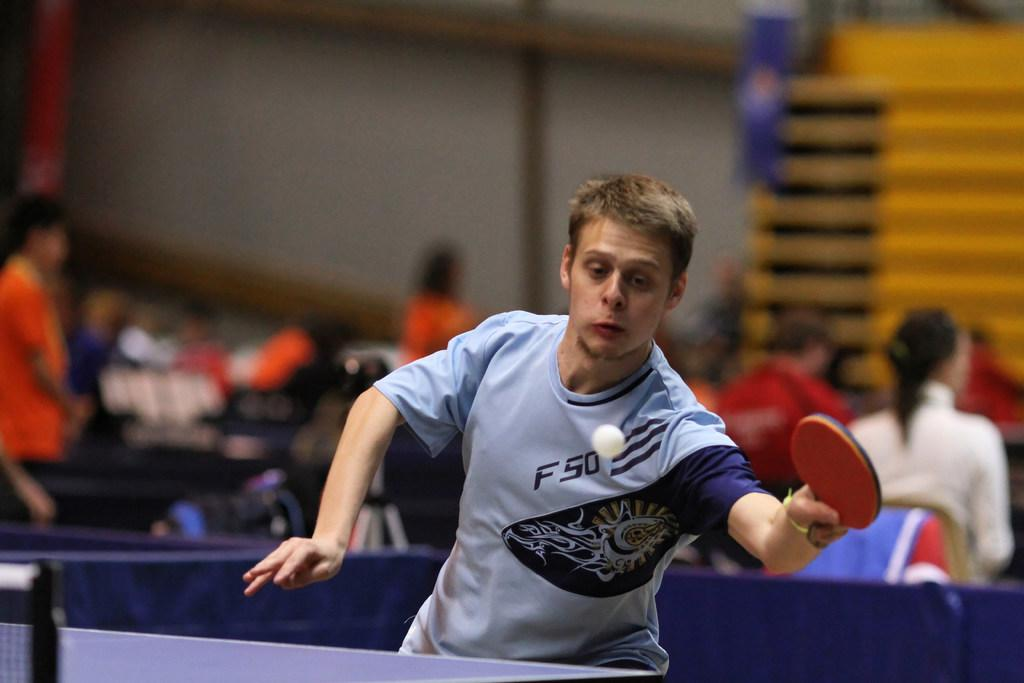What is the person in the image holding? The person in the image is holding a bat. How is the bat being held by the person? The person is holding the bat in his hand. What other object is present in the image? There is a ball in the image. What can be observed about the people in the background of the image? There are people sitting and standing in the background of the image. What type of tax is being discussed by the people in the image? There is no indication in the image that a tax discussion is taking place. --- Facts: 1. There is a car in the image. 2. The car is parked on the street. 3. There are trees on the side of the street. 4. The sky is visible in the image. 5. There are clouds in the sky. Absurd Topics: dance, piano, ocean Conversation: What is the main subject of the image? The main subject of the image is a car. Where is the car located in the image? The car is parked on the street. What can be seen on the side of the street? There are trees on the side of the street. What is visible in the background of the image? The sky is visible in the image, and there are clouds in the sky. Reasoning: Let's think step by step in order to produce the conversation. We start by identifying the main subject in the image, which is the car. Then, we expand the conversation to include details about the car's location and the presence of trees on the side of the street. Finally, we describe the sky and clouds visible in the background. Absurd Question/Answer: Can you hear the sound of the ocean in the image? There is no indication of the ocean or any related sounds in the image. 